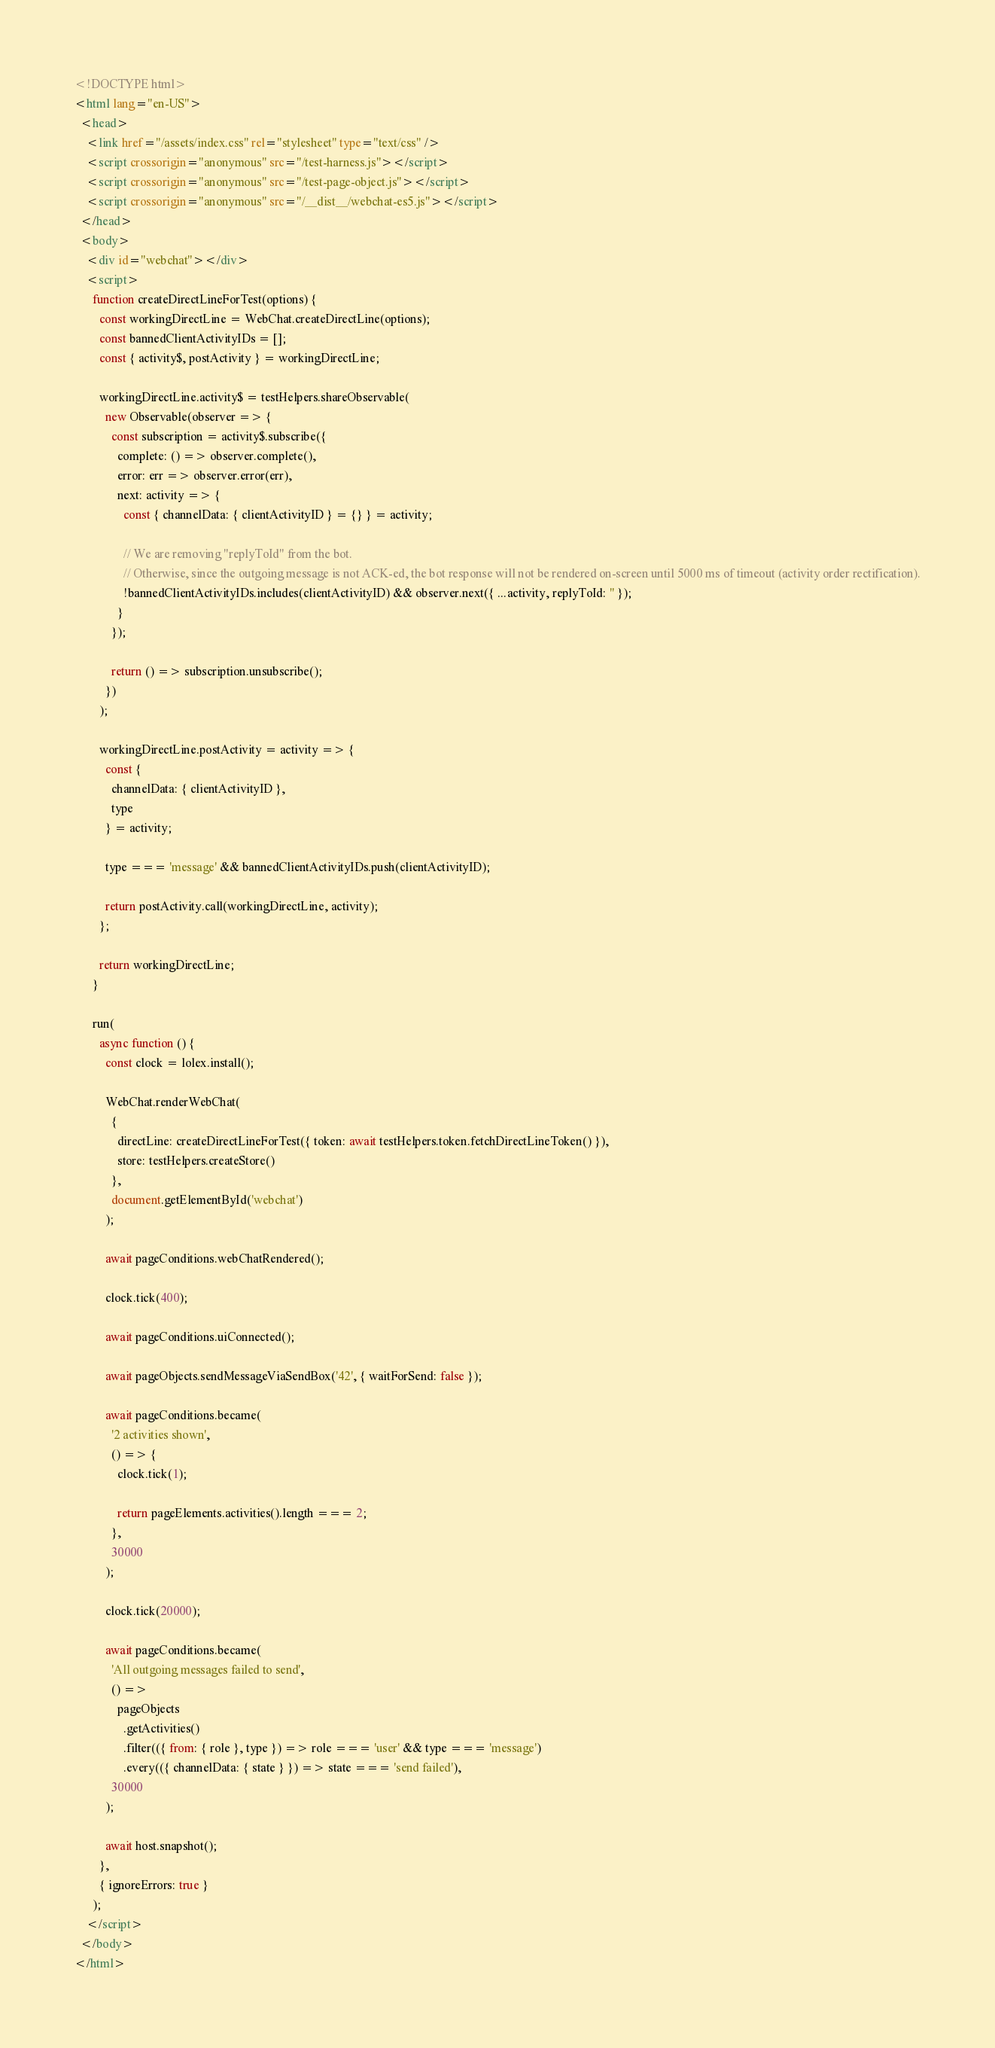<code> <loc_0><loc_0><loc_500><loc_500><_HTML_><!DOCTYPE html>
<html lang="en-US">
  <head>
    <link href="/assets/index.css" rel="stylesheet" type="text/css" />
    <script crossorigin="anonymous" src="/test-harness.js"></script>
    <script crossorigin="anonymous" src="/test-page-object.js"></script>
    <script crossorigin="anonymous" src="/__dist__/webchat-es5.js"></script>
  </head>
  <body>
    <div id="webchat"></div>
    <script>
      function createDirectLineForTest(options) {
        const workingDirectLine = WebChat.createDirectLine(options);
        const bannedClientActivityIDs = [];
        const { activity$, postActivity } = workingDirectLine;

        workingDirectLine.activity$ = testHelpers.shareObservable(
          new Observable(observer => {
            const subscription = activity$.subscribe({
              complete: () => observer.complete(),
              error: err => observer.error(err),
              next: activity => {
                const { channelData: { clientActivityID } = {} } = activity;

                // We are removing "replyToId" from the bot.
                // Otherwise, since the outgoing message is not ACK-ed, the bot response will not be rendered on-screen until 5000 ms of timeout (activity order rectification).
                !bannedClientActivityIDs.includes(clientActivityID) && observer.next({ ...activity, replyToId: '' });
              }
            });

            return () => subscription.unsubscribe();
          })
        );

        workingDirectLine.postActivity = activity => {
          const {
            channelData: { clientActivityID },
            type
          } = activity;

          type === 'message' && bannedClientActivityIDs.push(clientActivityID);

          return postActivity.call(workingDirectLine, activity);
        };

        return workingDirectLine;
      }

      run(
        async function () {
          const clock = lolex.install();

          WebChat.renderWebChat(
            {
              directLine: createDirectLineForTest({ token: await testHelpers.token.fetchDirectLineToken() }),
              store: testHelpers.createStore()
            },
            document.getElementById('webchat')
          );

          await pageConditions.webChatRendered();

          clock.tick(400);

          await pageConditions.uiConnected();

          await pageObjects.sendMessageViaSendBox('42', { waitForSend: false });

          await pageConditions.became(
            '2 activities shown',
            () => {
              clock.tick(1);

              return pageElements.activities().length === 2;
            },
            30000
          );

          clock.tick(20000);

          await pageConditions.became(
            'All outgoing messages failed to send',
            () =>
              pageObjects
                .getActivities()
                .filter(({ from: { role }, type }) => role === 'user' && type === 'message')
                .every(({ channelData: { state } }) => state === 'send failed'),
            30000
          );

          await host.snapshot();
        },
        { ignoreErrors: true }
      );
    </script>
  </body>
</html>
</code> 